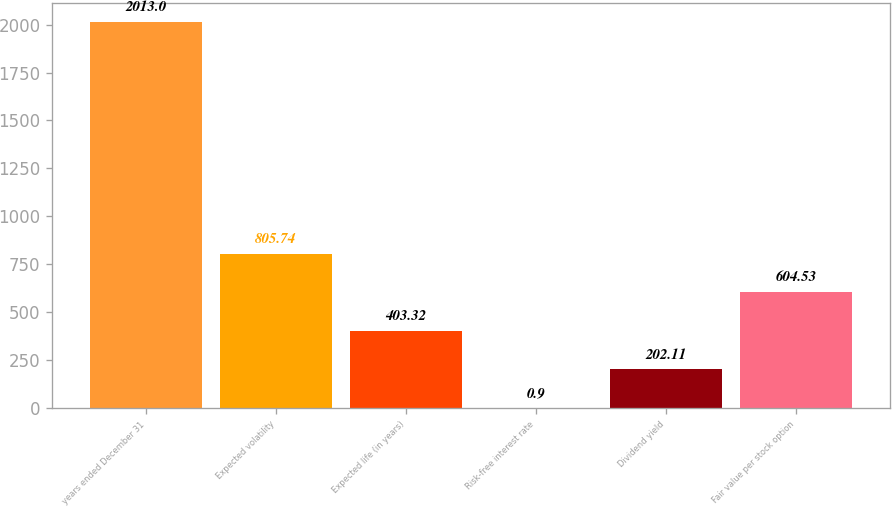Convert chart to OTSL. <chart><loc_0><loc_0><loc_500><loc_500><bar_chart><fcel>years ended December 31<fcel>Expected volatility<fcel>Expected life (in years)<fcel>Risk-free interest rate<fcel>Dividend yield<fcel>Fair value per stock option<nl><fcel>2013<fcel>805.74<fcel>403.32<fcel>0.9<fcel>202.11<fcel>604.53<nl></chart> 